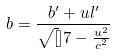Convert formula to latex. <formula><loc_0><loc_0><loc_500><loc_500>b = \frac { b ^ { \prime } + u l ^ { \prime } } { \sqrt { [ } ] { 7 - \frac { u ^ { 2 } } { c ^ { 2 } } } }</formula> 